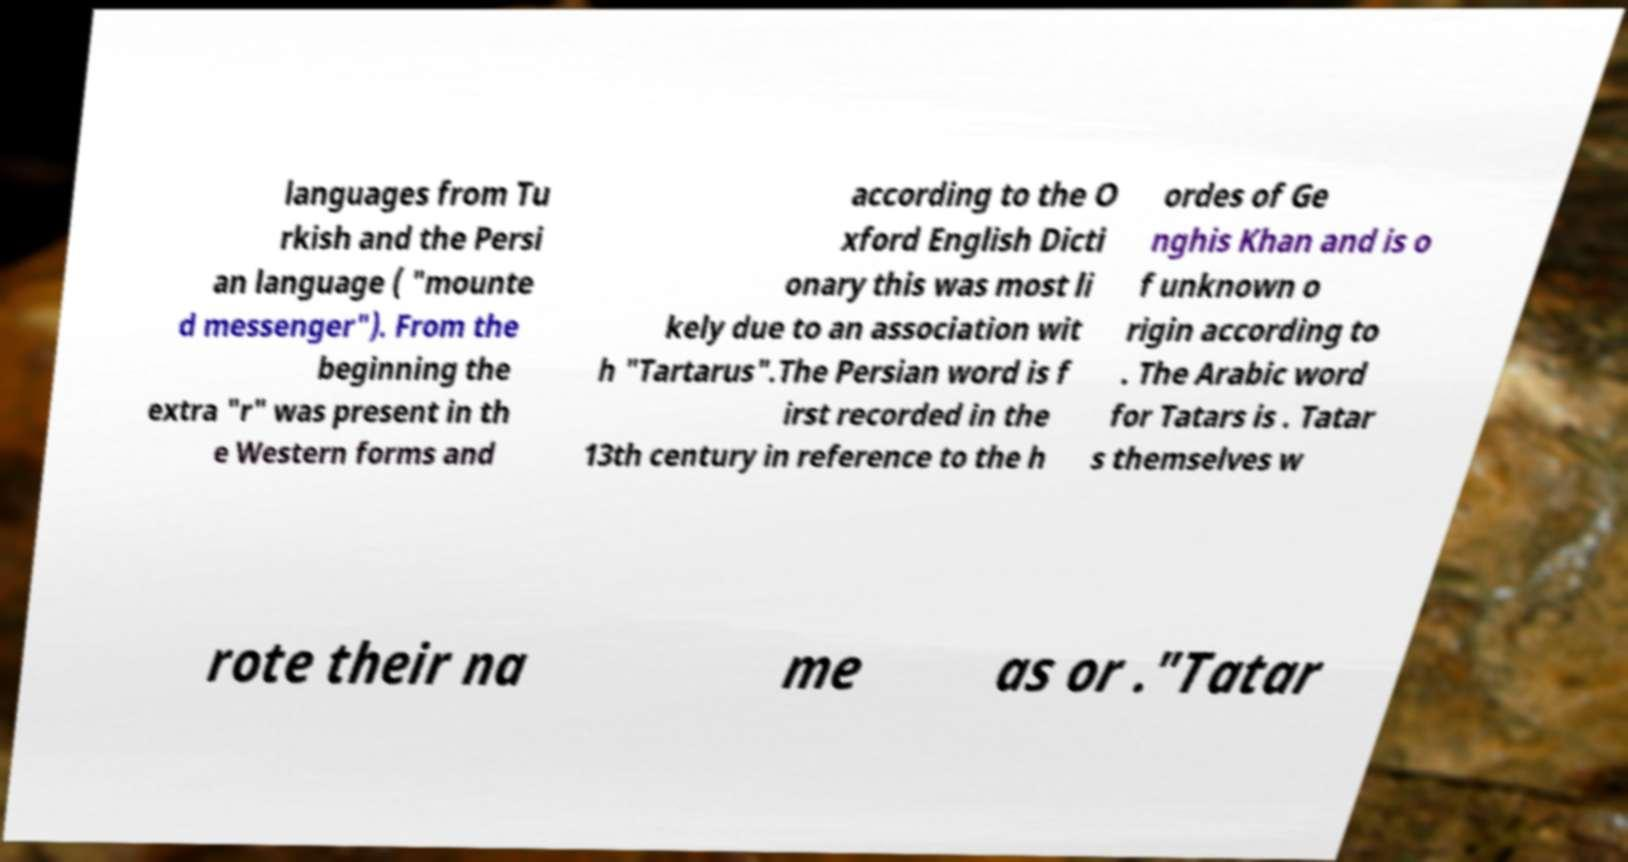Could you extract and type out the text from this image? languages from Tu rkish and the Persi an language ( "mounte d messenger"). From the beginning the extra "r" was present in th e Western forms and according to the O xford English Dicti onary this was most li kely due to an association wit h "Tartarus".The Persian word is f irst recorded in the 13th century in reference to the h ordes of Ge nghis Khan and is o f unknown o rigin according to . The Arabic word for Tatars is . Tatar s themselves w rote their na me as or ."Tatar 